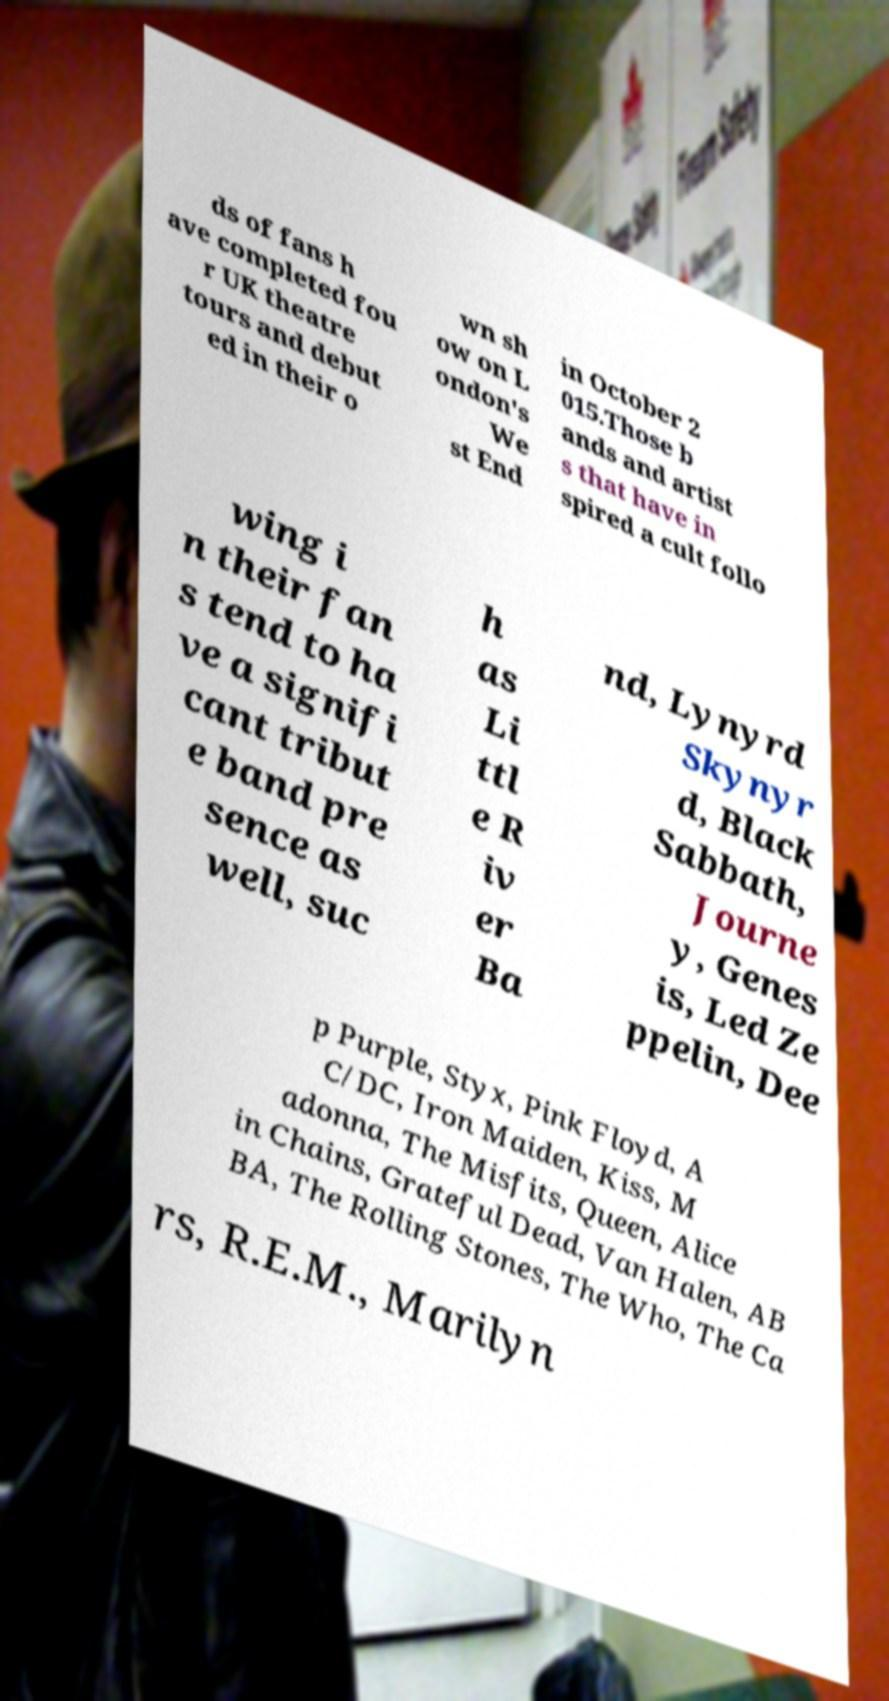Please read and relay the text visible in this image. What does it say? ds of fans h ave completed fou r UK theatre tours and debut ed in their o wn sh ow on L ondon's We st End in October 2 015.Those b ands and artist s that have in spired a cult follo wing i n their fan s tend to ha ve a signifi cant tribut e band pre sence as well, suc h as Li ttl e R iv er Ba nd, Lynyrd Skynyr d, Black Sabbath, Journe y, Genes is, Led Ze ppelin, Dee p Purple, Styx, Pink Floyd, A C/DC, Iron Maiden, Kiss, M adonna, The Misfits, Queen, Alice in Chains, Grateful Dead, Van Halen, AB BA, The Rolling Stones, The Who, The Ca rs, R.E.M., Marilyn 